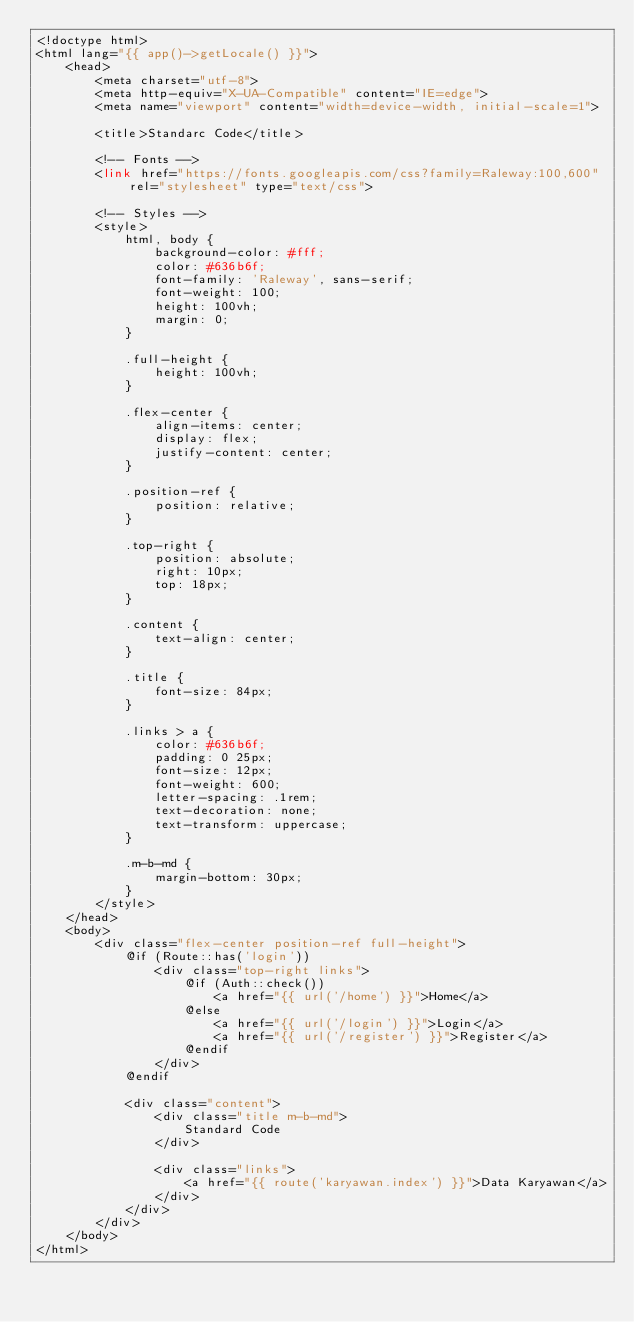<code> <loc_0><loc_0><loc_500><loc_500><_PHP_><!doctype html>
<html lang="{{ app()->getLocale() }}">
    <head>
        <meta charset="utf-8">
        <meta http-equiv="X-UA-Compatible" content="IE=edge">
        <meta name="viewport" content="width=device-width, initial-scale=1">

        <title>Standarc Code</title>

        <!-- Fonts -->
        <link href="https://fonts.googleapis.com/css?family=Raleway:100,600" rel="stylesheet" type="text/css">

        <!-- Styles -->
        <style>
            html, body {
                background-color: #fff;
                color: #636b6f;
                font-family: 'Raleway', sans-serif;
                font-weight: 100;
                height: 100vh;
                margin: 0;
            }

            .full-height {
                height: 100vh;
            }

            .flex-center {
                align-items: center;
                display: flex;
                justify-content: center;
            }

            .position-ref {
                position: relative;
            }

            .top-right {
                position: absolute;
                right: 10px;
                top: 18px;
            }

            .content {
                text-align: center;
            }

            .title {
                font-size: 84px;
            }

            .links > a {
                color: #636b6f;
                padding: 0 25px;
                font-size: 12px;
                font-weight: 600;
                letter-spacing: .1rem;
                text-decoration: none;
                text-transform: uppercase;
            }

            .m-b-md {
                margin-bottom: 30px;
            }
        </style>
    </head>
    <body>
        <div class="flex-center position-ref full-height">
            @if (Route::has('login'))
                <div class="top-right links">
                    @if (Auth::check())
                        <a href="{{ url('/home') }}">Home</a>
                    @else
                        <a href="{{ url('/login') }}">Login</a>
                        <a href="{{ url('/register') }}">Register</a>
                    @endif
                </div>
            @endif

            <div class="content">
                <div class="title m-b-md">
                    Standard Code
                </div>

                <div class="links">
                    <a href="{{ route('karyawan.index') }}">Data Karyawan</a>
                </div>
            </div>
        </div>
    </body>
</html>
</code> 